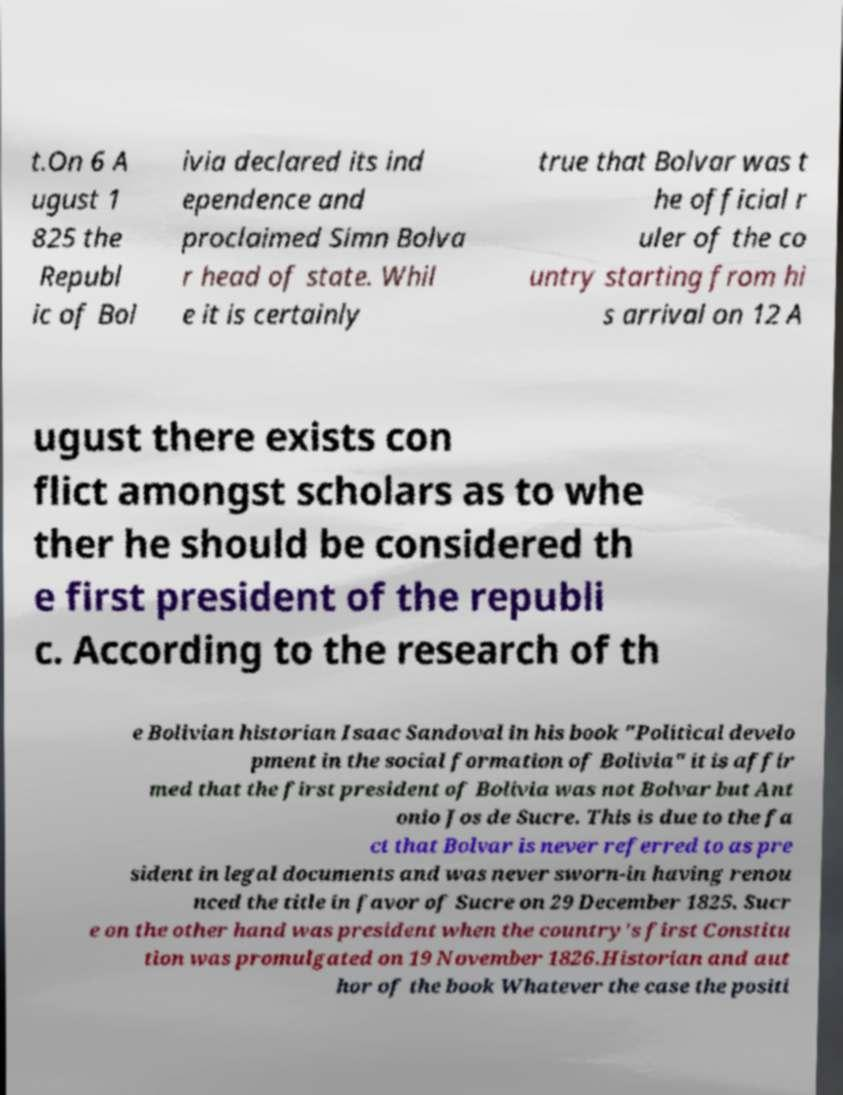What messages or text are displayed in this image? I need them in a readable, typed format. t.On 6 A ugust 1 825 the Republ ic of Bol ivia declared its ind ependence and proclaimed Simn Bolva r head of state. Whil e it is certainly true that Bolvar was t he official r uler of the co untry starting from hi s arrival on 12 A ugust there exists con flict amongst scholars as to whe ther he should be considered th e first president of the republi c. According to the research of th e Bolivian historian Isaac Sandoval in his book "Political develo pment in the social formation of Bolivia" it is affir med that the first president of Bolivia was not Bolvar but Ant onio Jos de Sucre. This is due to the fa ct that Bolvar is never referred to as pre sident in legal documents and was never sworn-in having renou nced the title in favor of Sucre on 29 December 1825. Sucr e on the other hand was president when the country's first Constitu tion was promulgated on 19 November 1826.Historian and aut hor of the book Whatever the case the positi 